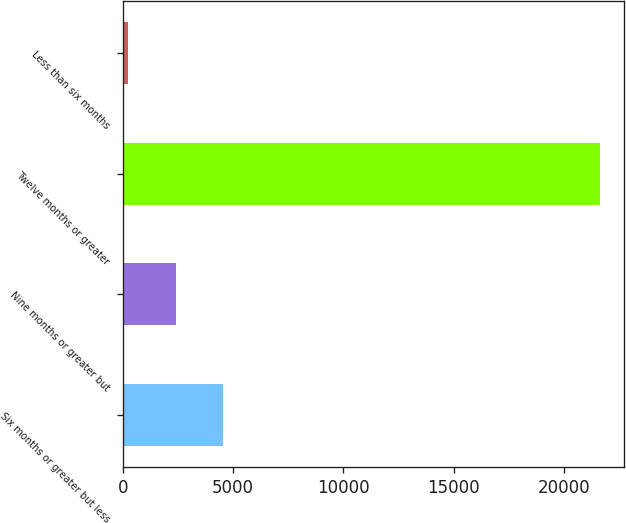Convert chart. <chart><loc_0><loc_0><loc_500><loc_500><bar_chart><fcel>Six months or greater but less<fcel>Nine months or greater but<fcel>Twelve months or greater<fcel>Less than six months<nl><fcel>4523<fcel>2385<fcel>21627<fcel>247<nl></chart> 